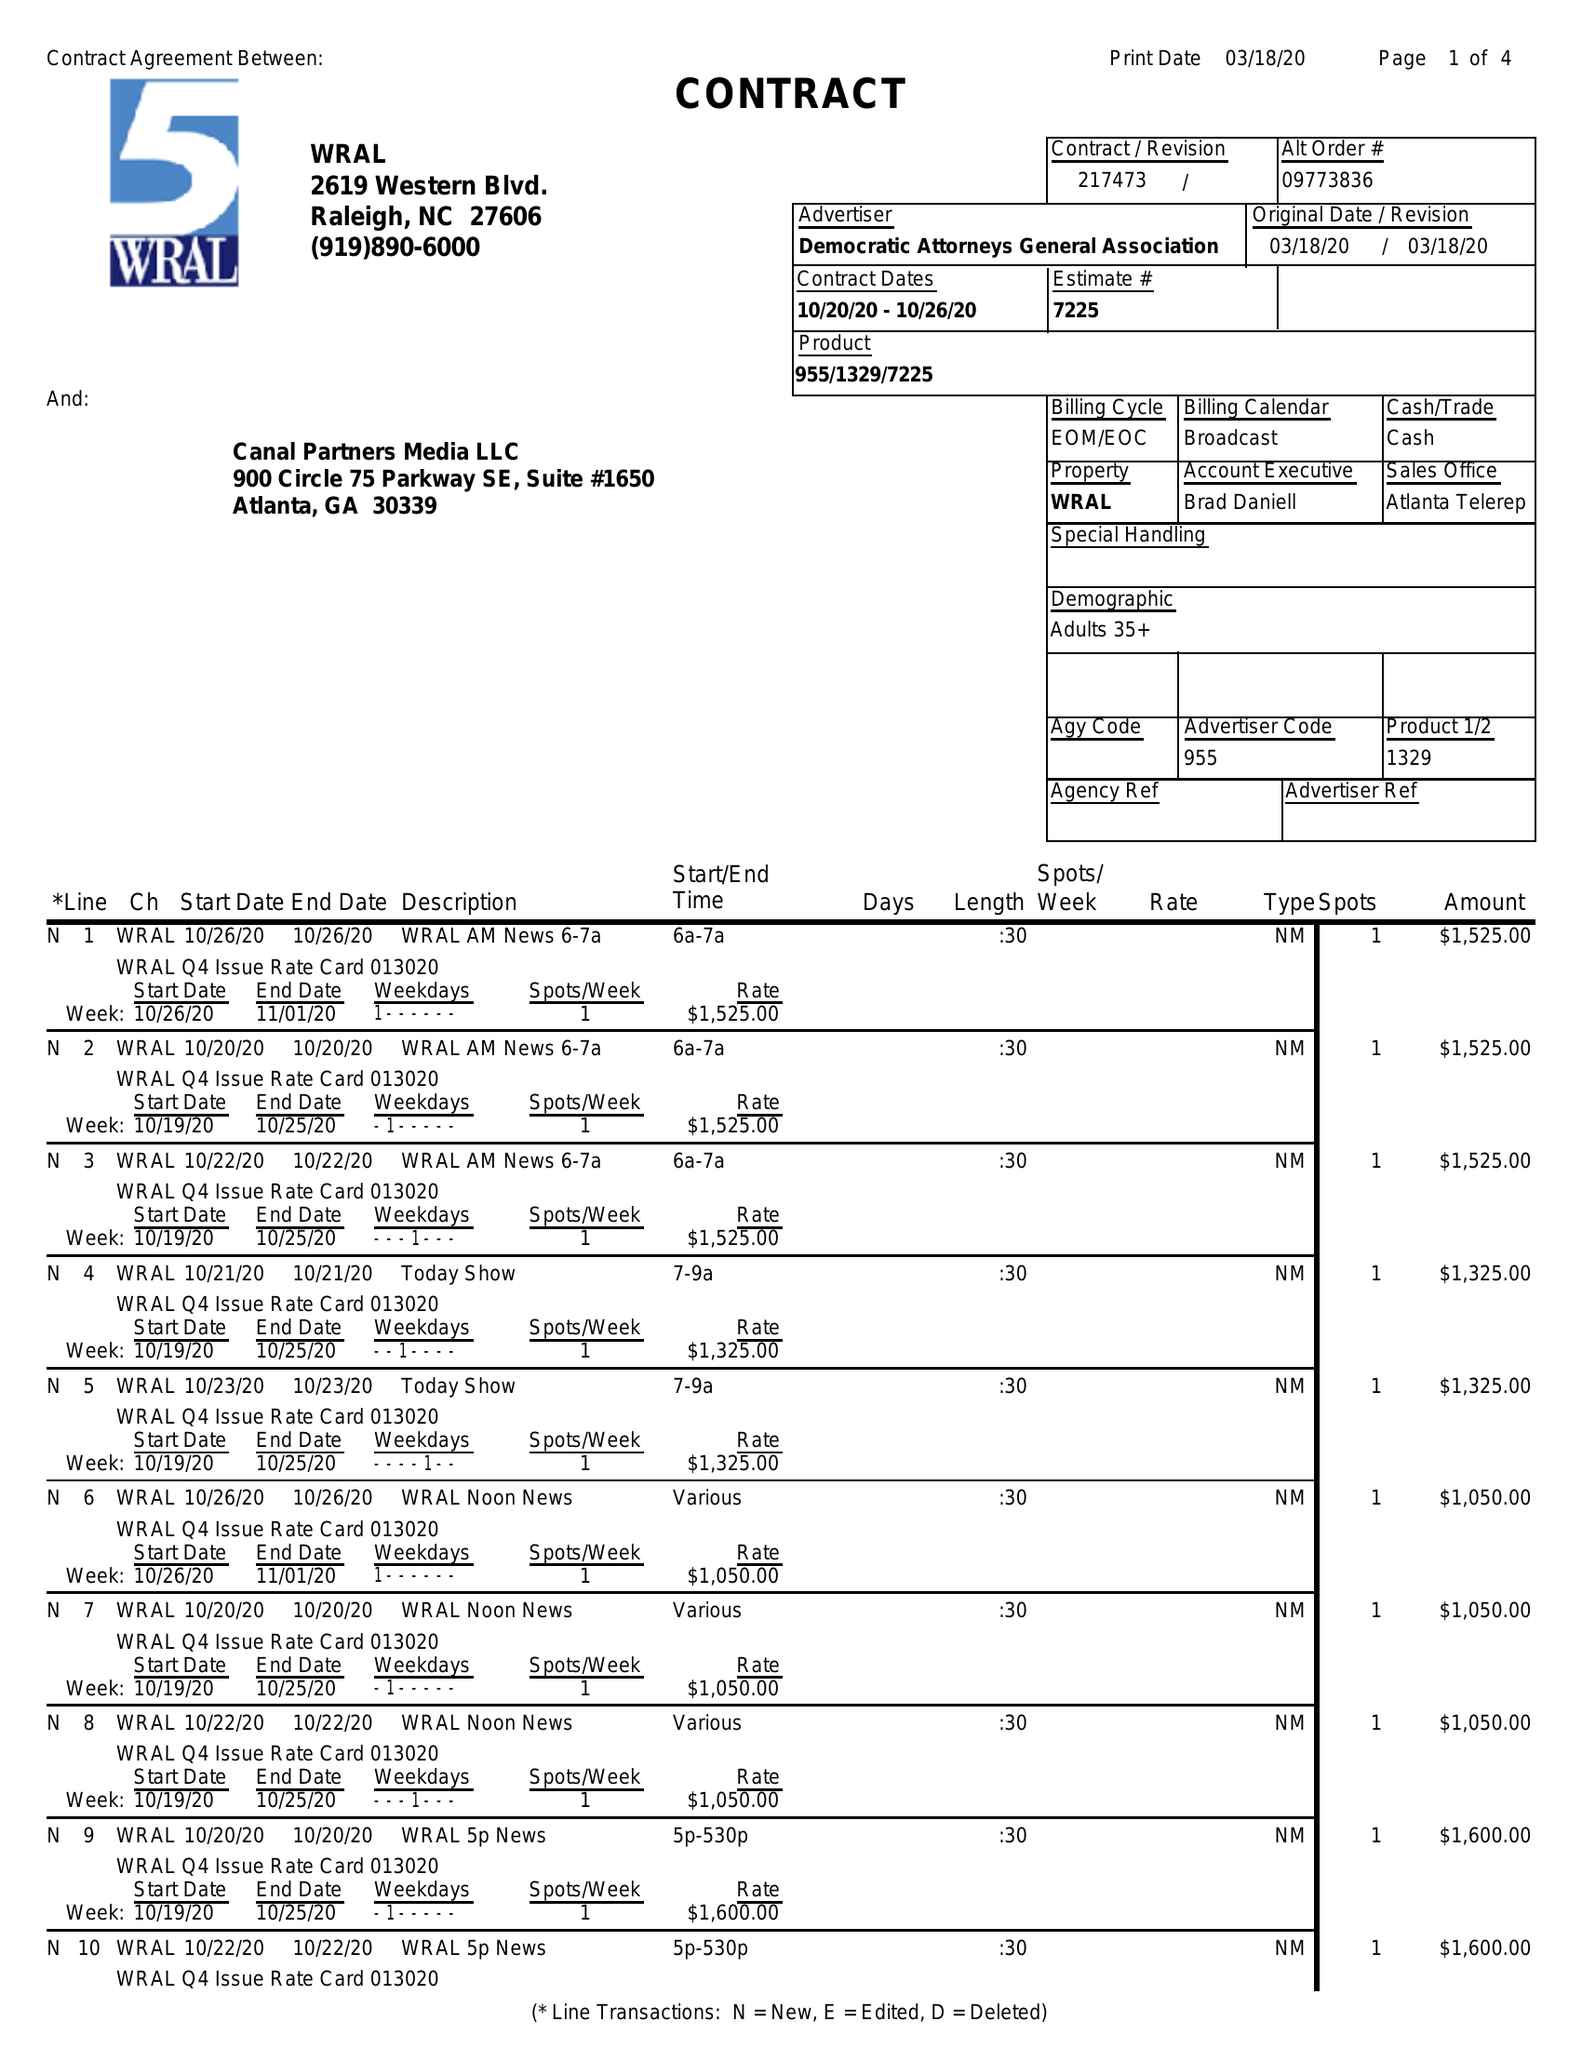What is the value for the advertiser?
Answer the question using a single word or phrase. DEMOCRATIC ATTORNEYS GENERAL ASSOCIATION 